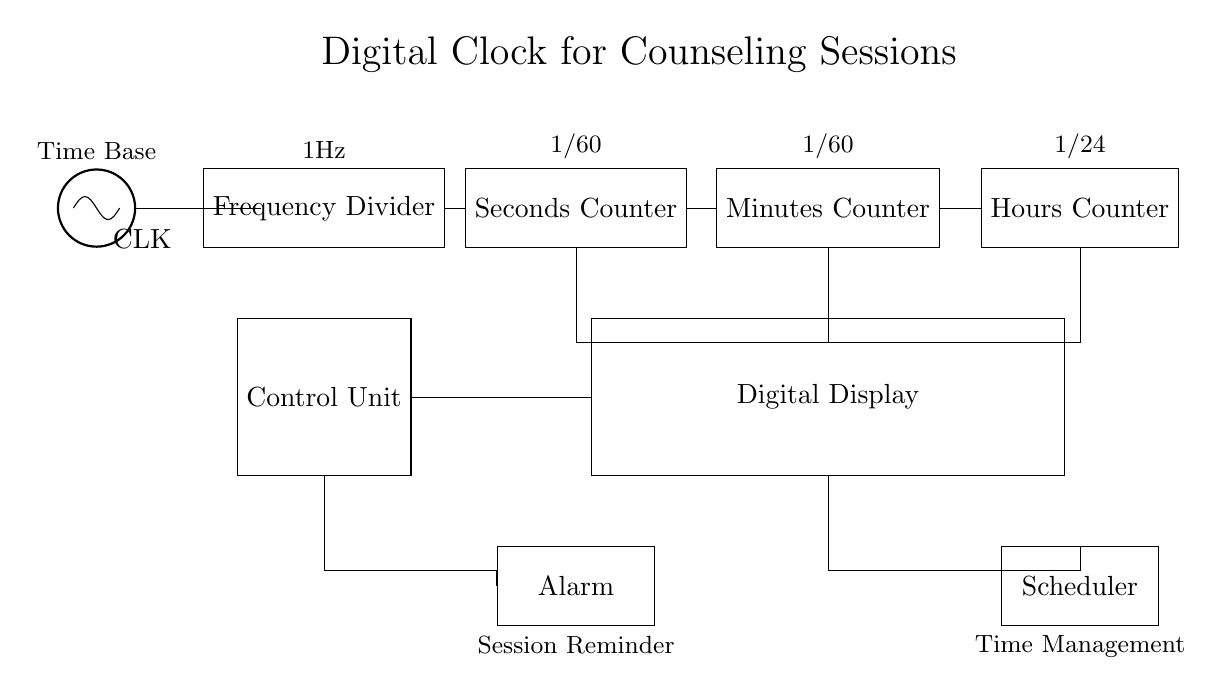What is the main function of the CLK component? The CLK component acts as a time base generator, providing the clock signal to drive the entire clock circuit. It generates a pulse signal that is used to synchronize operations in the subsequent components.
Answer: Time base generator What does the Frequency Divider do in this circuit? The Frequency Divider takes the clock signal from CLK and reduces its frequency, generating a 1 Hz output signal, which is essential for counting seconds correctly in the clock circuit.
Answer: Reduces frequency How many types of counters are present in the circuit? The circuit includes three distinct counters: a Seconds Counter, a Minutes Counter, and an Hours Counter, each responsible for counting different time units.
Answer: Three What is the output connection of the Seconds Counter? The output of the Seconds Counter connects to the Minutes Counter, enabling it to increment as every sixty seconds are counted.
Answer: Minutes Counter What is the role of the Control Unit? The Control Unit oversees the operations of the digital clock, controlling interactions between the counters and the display, ensuring that the correct time is shown based on the counted values.
Answer: Oversees operations How does the Scheduler interact with the Digital Display? The Scheduler receives information from the Digital Display regarding the current time and manages reminders or alerts for timed sessions, aiding in time management during counseling sessions.
Answer: Manages reminders 